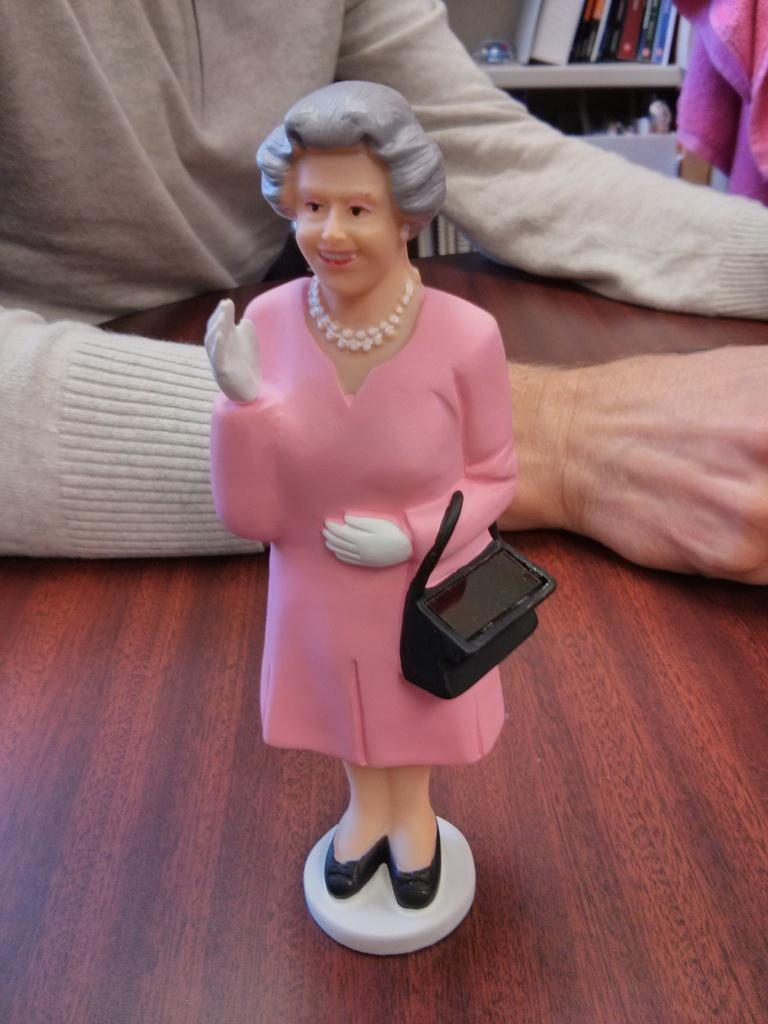What is the main subject on the table in the image? There is a miniature on a table in the image. What can be seen near the miniature? A person's hands are on the table. What is visible in the background of the image? There are books on racks and a cloth in the background. What type of trouble is the vessel experiencing in the image? There is no vessel or trouble present in the image; it features a miniature on a table with a person's hands nearby and books on racks in the background. 